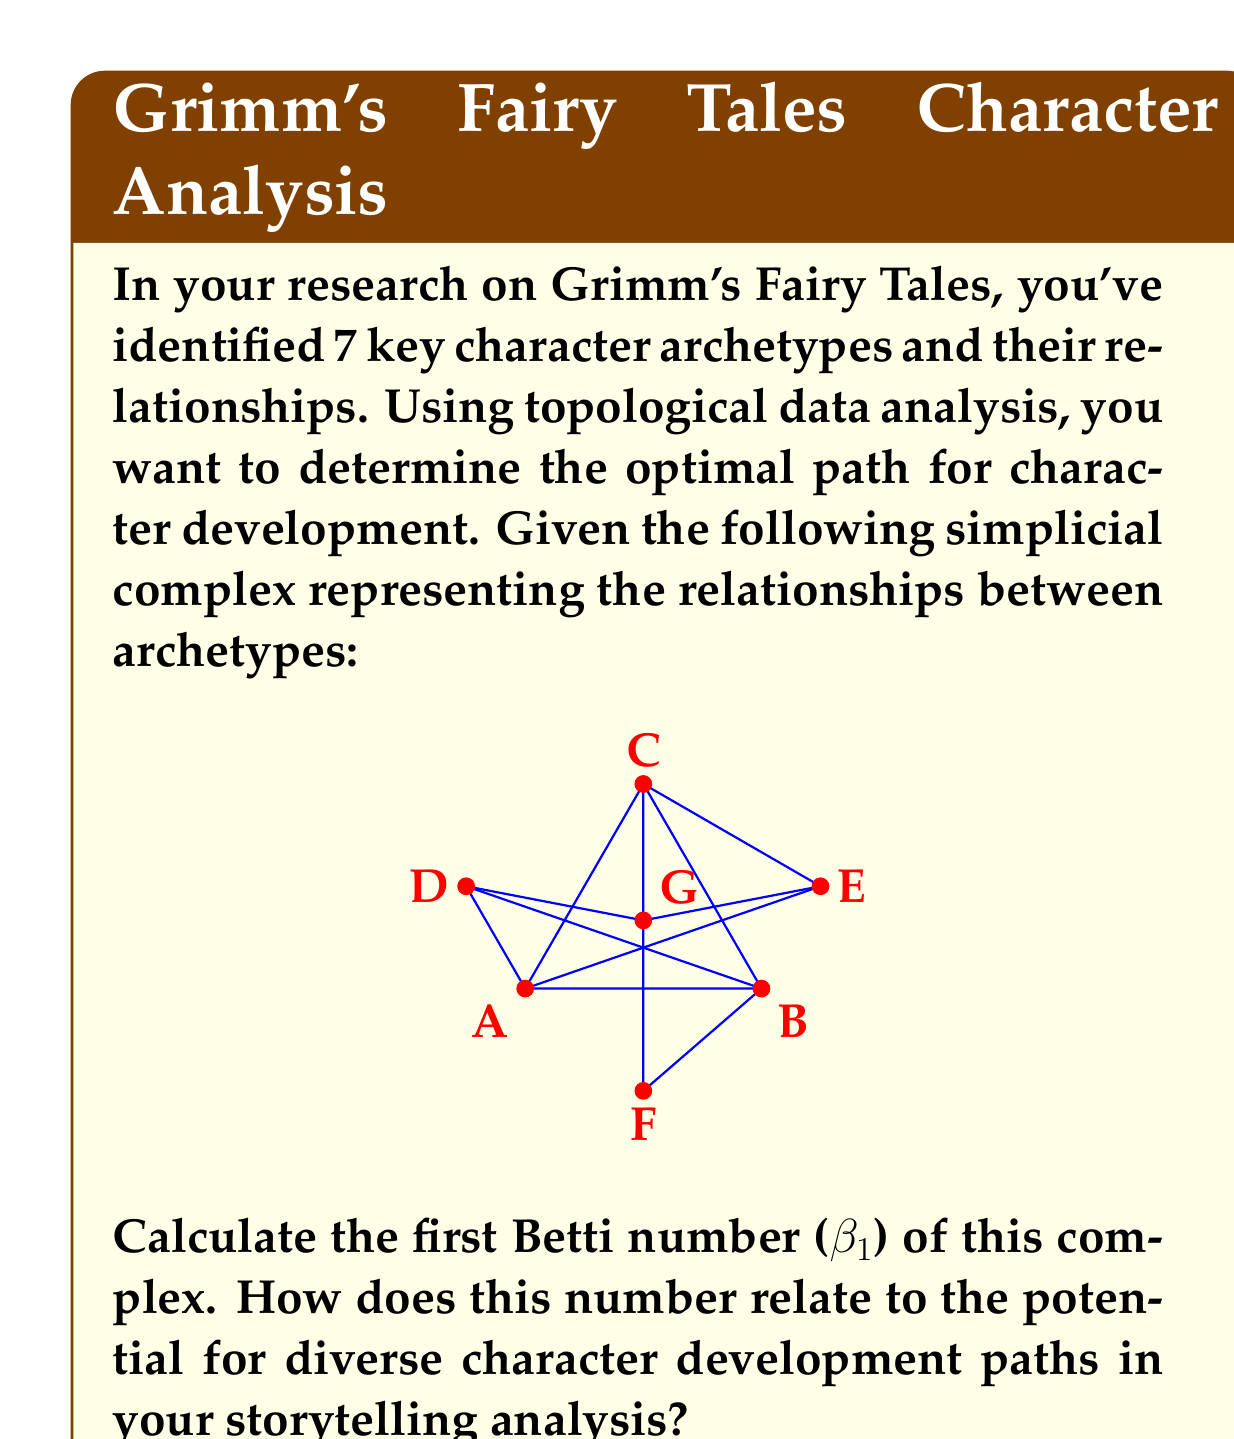Solve this math problem. To solve this problem, we need to understand the concept of Betti numbers in topological data analysis and how they relate to the simplicial complex given.

1) First, let's recall what Betti numbers represent:
   - $\beta_0$ is the number of connected components
   - $\beta_1$ is the number of 1-dimensional holes (loops)
   - $\beta_2$ is the number of 2-dimensional voids
   - and so on...

2) In our case, we're interested in $\beta_1$, which represents the number of loops in the simplicial complex.

3) To calculate $\beta_1$, we need to count the number of independent loops in the complex. A loop is considered independent if it can't be formed by combining other loops.

4) Looking at the given simplicial complex, we can identify the following independent loops:
   - ABCA
   - ABDA
   - ACEGA
   - BCFGB

5) Therefore, $\beta_1 = 4$

6) In the context of character development in storytelling:
   - Each vertex (A, B, C, D, E, F, G) represents a character archetype
   - Each edge represents a possible transition or relationship between archetypes
   - Each loop represents a cycle of character development or a circular narrative structure

7) The Betti number $\beta_1 = 4$ indicates that there are four distinct cyclic paths for character development in this storytelling framework based on Grimm's Fairy Tales.

8) This suggests a rich potential for diverse character arcs and narrative structures. Characters can evolve through multiple cyclic paths, allowing for complex and varied storytelling possibilities.

9) In your analysis of Grimm's Fairy Tales and their influence on Western storytelling, this topological approach reveals the intricate structure of character relationships and development paths inherent in these classic tales.
Answer: The first Betti number ($\beta_1$) of the given simplicial complex is 4. This indicates four distinct cyclic paths for character development, suggesting a rich potential for diverse character arcs and narrative structures in the storytelling analysis of Grimm's Fairy Tales. 